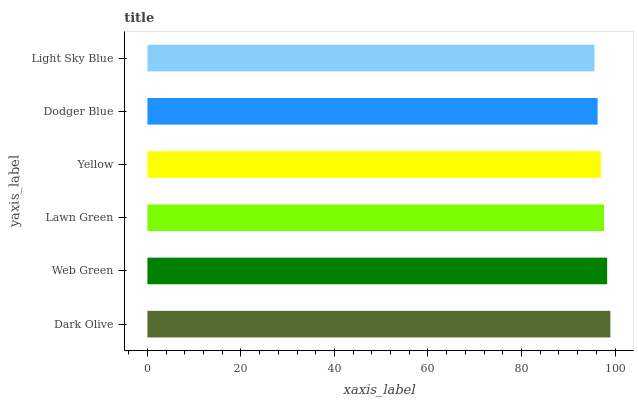Is Light Sky Blue the minimum?
Answer yes or no. Yes. Is Dark Olive the maximum?
Answer yes or no. Yes. Is Web Green the minimum?
Answer yes or no. No. Is Web Green the maximum?
Answer yes or no. No. Is Dark Olive greater than Web Green?
Answer yes or no. Yes. Is Web Green less than Dark Olive?
Answer yes or no. Yes. Is Web Green greater than Dark Olive?
Answer yes or no. No. Is Dark Olive less than Web Green?
Answer yes or no. No. Is Lawn Green the high median?
Answer yes or no. Yes. Is Yellow the low median?
Answer yes or no. Yes. Is Dodger Blue the high median?
Answer yes or no. No. Is Dark Olive the low median?
Answer yes or no. No. 